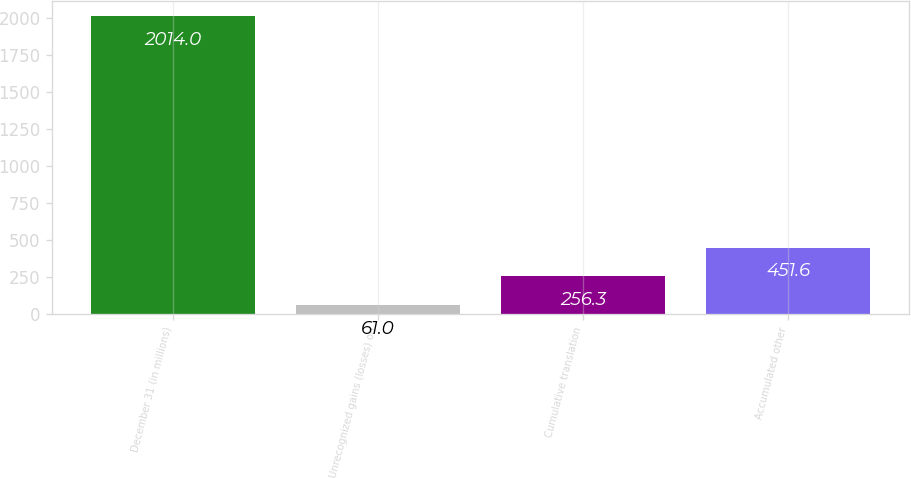Convert chart. <chart><loc_0><loc_0><loc_500><loc_500><bar_chart><fcel>December 31 (in millions)<fcel>Unrecognized gains (losses) on<fcel>Cumulative translation<fcel>Accumulated other<nl><fcel>2014<fcel>61<fcel>256.3<fcel>451.6<nl></chart> 